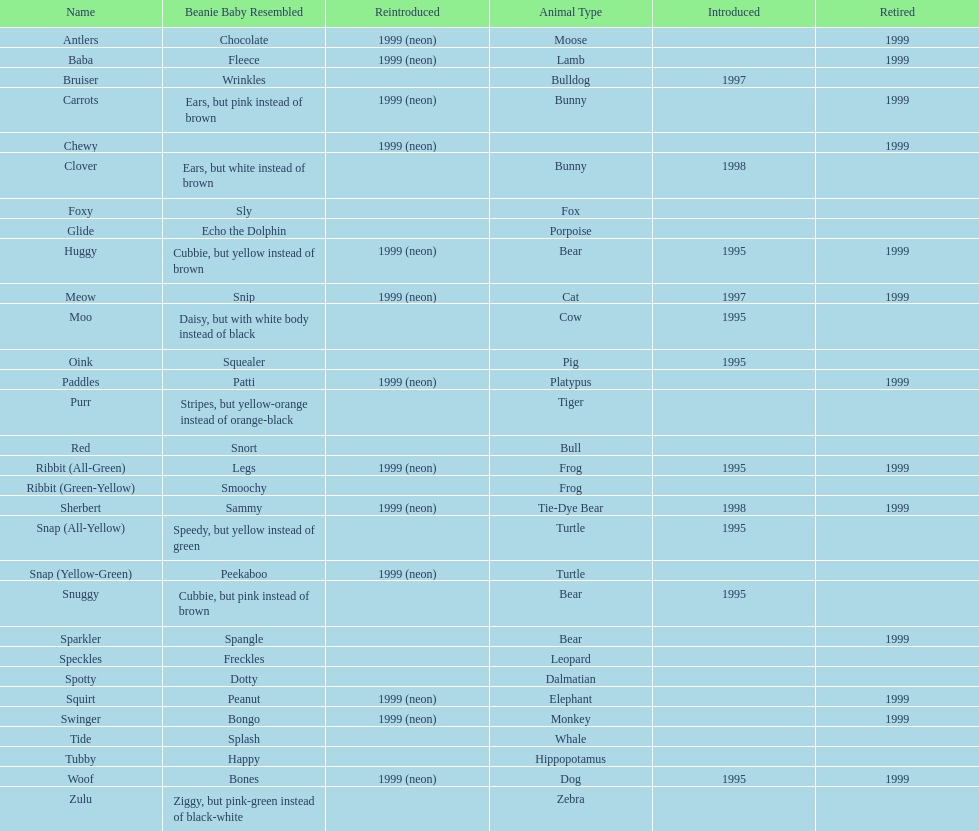How many monkey pillow pals were there? 1. 